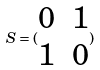<formula> <loc_0><loc_0><loc_500><loc_500>S = ( \begin{matrix} 0 & 1 \\ 1 & 0 \end{matrix} )</formula> 